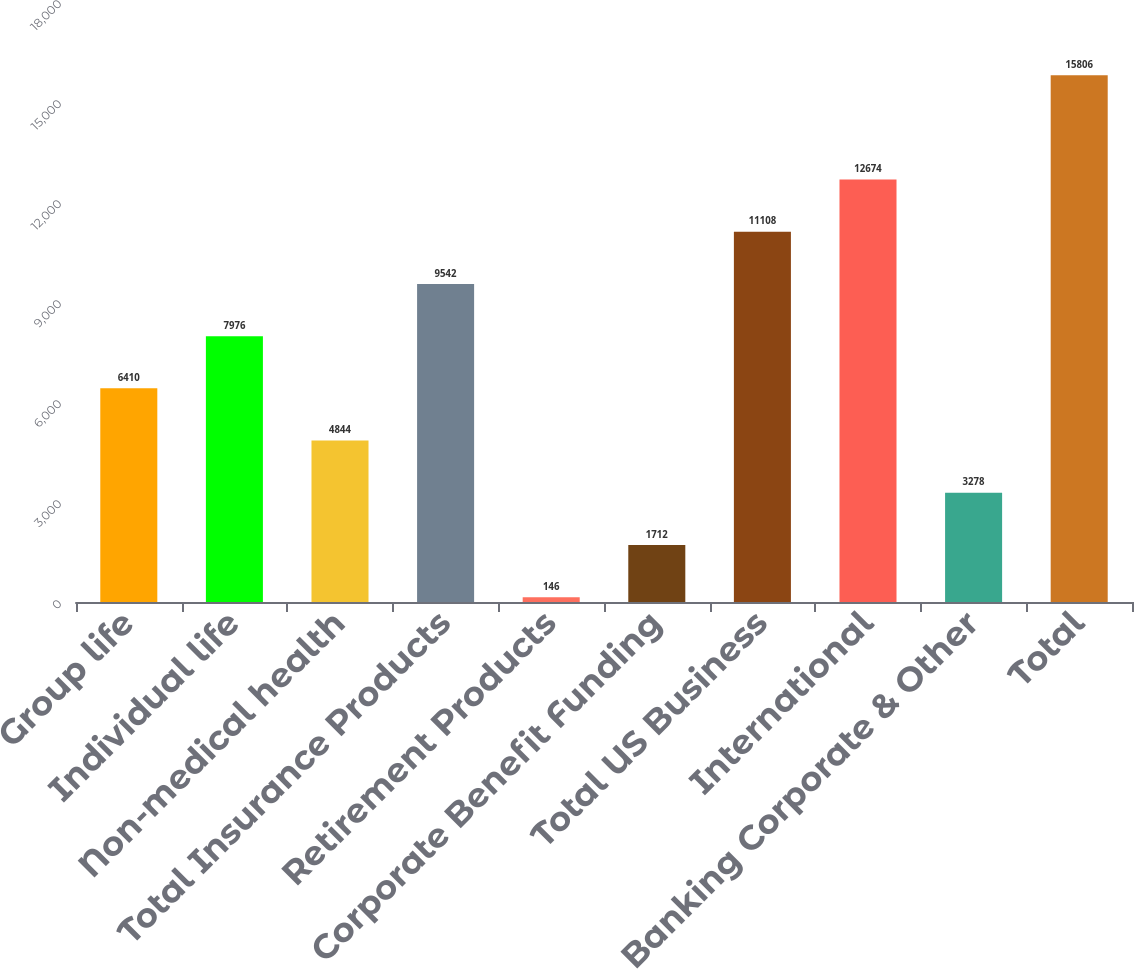Convert chart. <chart><loc_0><loc_0><loc_500><loc_500><bar_chart><fcel>Group life<fcel>Individual life<fcel>Non-medical health<fcel>Total Insurance Products<fcel>Retirement Products<fcel>Corporate Benefit Funding<fcel>Total US Business<fcel>International<fcel>Banking Corporate & Other<fcel>Total<nl><fcel>6410<fcel>7976<fcel>4844<fcel>9542<fcel>146<fcel>1712<fcel>11108<fcel>12674<fcel>3278<fcel>15806<nl></chart> 